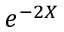Convert formula to latex. <formula><loc_0><loc_0><loc_500><loc_500>e ^ { - 2 { X } }</formula> 